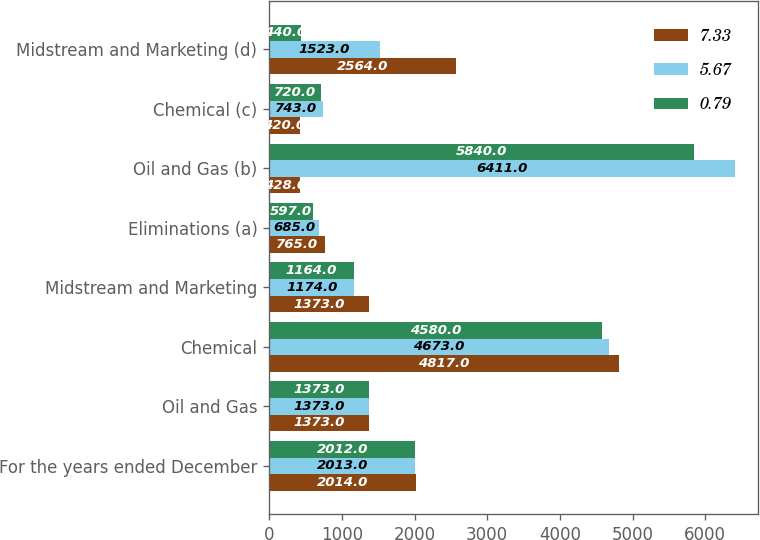<chart> <loc_0><loc_0><loc_500><loc_500><stacked_bar_chart><ecel><fcel>For the years ended December<fcel>Oil and Gas<fcel>Chemical<fcel>Midstream and Marketing<fcel>Eliminations (a)<fcel>Oil and Gas (b)<fcel>Chemical (c)<fcel>Midstream and Marketing (d)<nl><fcel>7.33<fcel>2014<fcel>1373<fcel>4817<fcel>1373<fcel>765<fcel>428<fcel>420<fcel>2564<nl><fcel>5.67<fcel>2013<fcel>1373<fcel>4673<fcel>1174<fcel>685<fcel>6411<fcel>743<fcel>1523<nl><fcel>0.79<fcel>2012<fcel>1373<fcel>4580<fcel>1164<fcel>597<fcel>5840<fcel>720<fcel>440<nl></chart> 